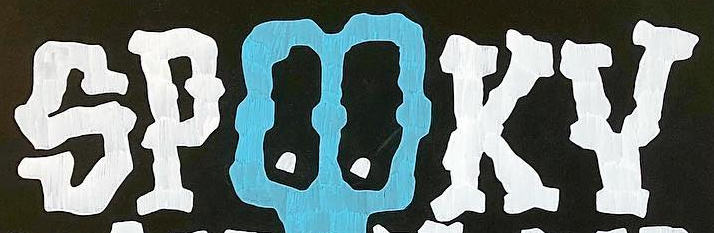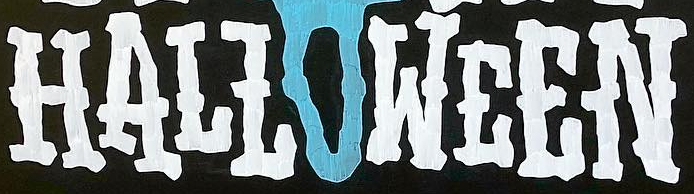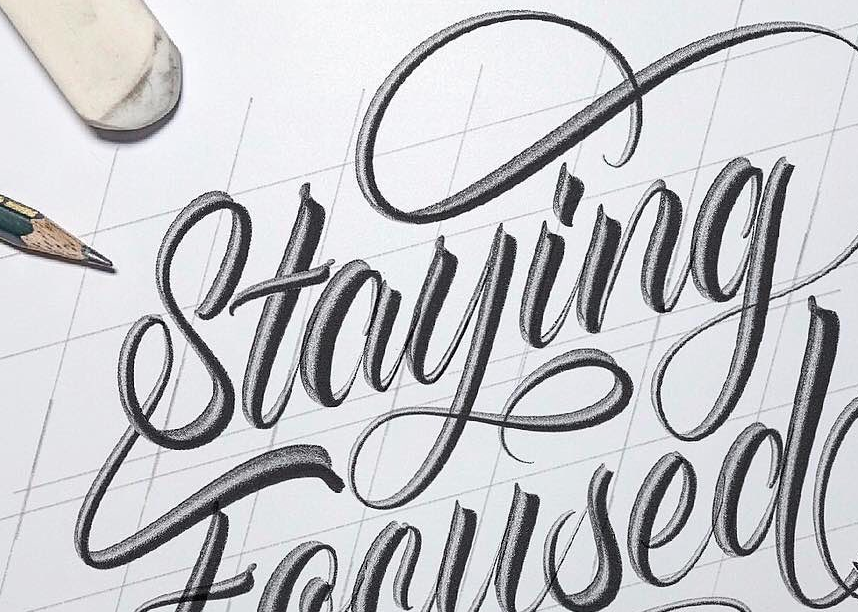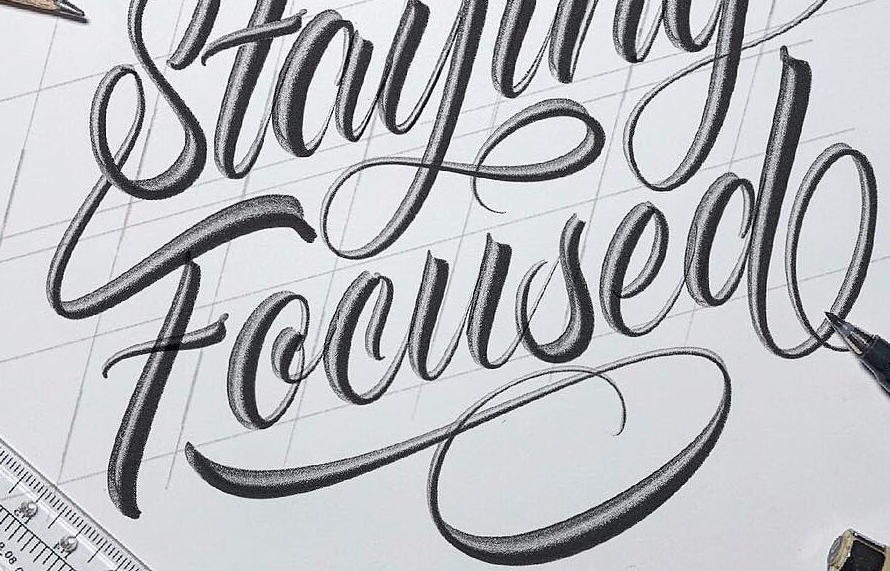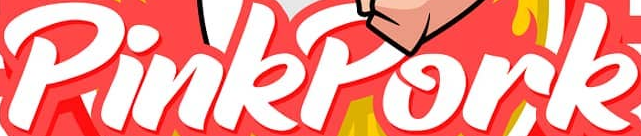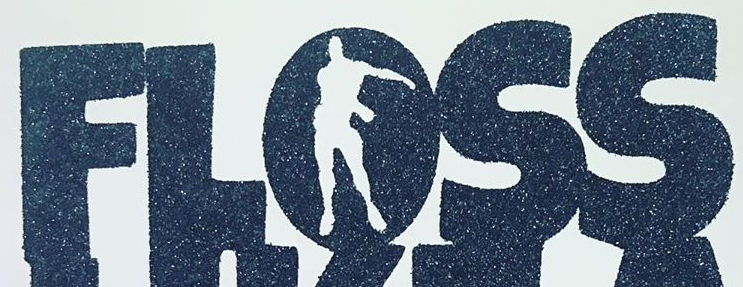Read the text content from these images in order, separated by a semicolon. SPOOKY; HALLOWEEN; Staying; Focused; PinkPork; FLOSS 